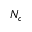Convert formula to latex. <formula><loc_0><loc_0><loc_500><loc_500>N _ { c }</formula> 